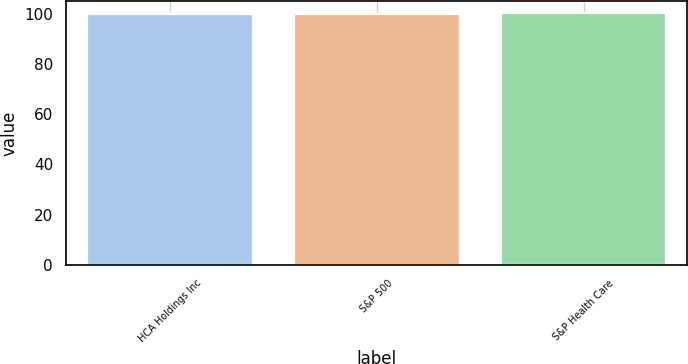Convert chart to OTSL. <chart><loc_0><loc_0><loc_500><loc_500><bar_chart><fcel>HCA Holdings Inc<fcel>S&P 500<fcel>S&P Health Care<nl><fcel>100<fcel>100.1<fcel>100.2<nl></chart> 